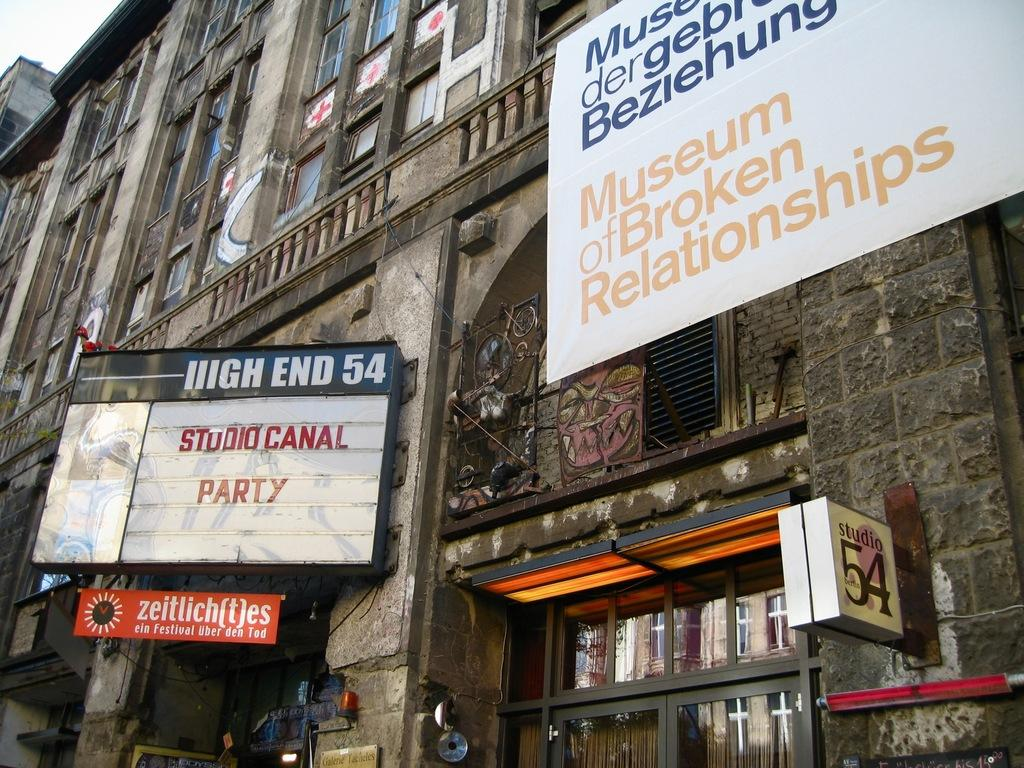What is the main subject in the center of the image? There are buildings in the center of the image. What can be seen on the boards in the image? There are boards with text in the image. What type of entrance is visible at the bottom of the image? There is a glass door at the bottom of the image. Can you describe any other objects present in the image? There are other objects present in the image, but their specific details are not mentioned in the provided facts. What is the tendency of the land in the image? The provided facts do not mention any land or terrain in the image, so it is not possible to determine the tendency of the land. 